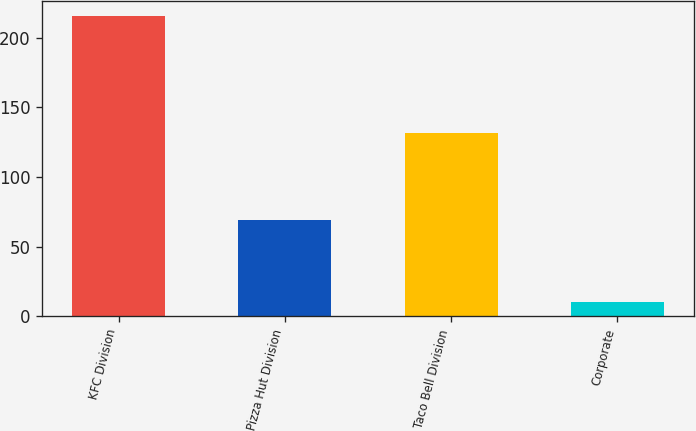Convert chart to OTSL. <chart><loc_0><loc_0><loc_500><loc_500><bar_chart><fcel>KFC Division<fcel>Pizza Hut Division<fcel>Taco Bell Division<fcel>Corporate<nl><fcel>216<fcel>69<fcel>132<fcel>10<nl></chart> 